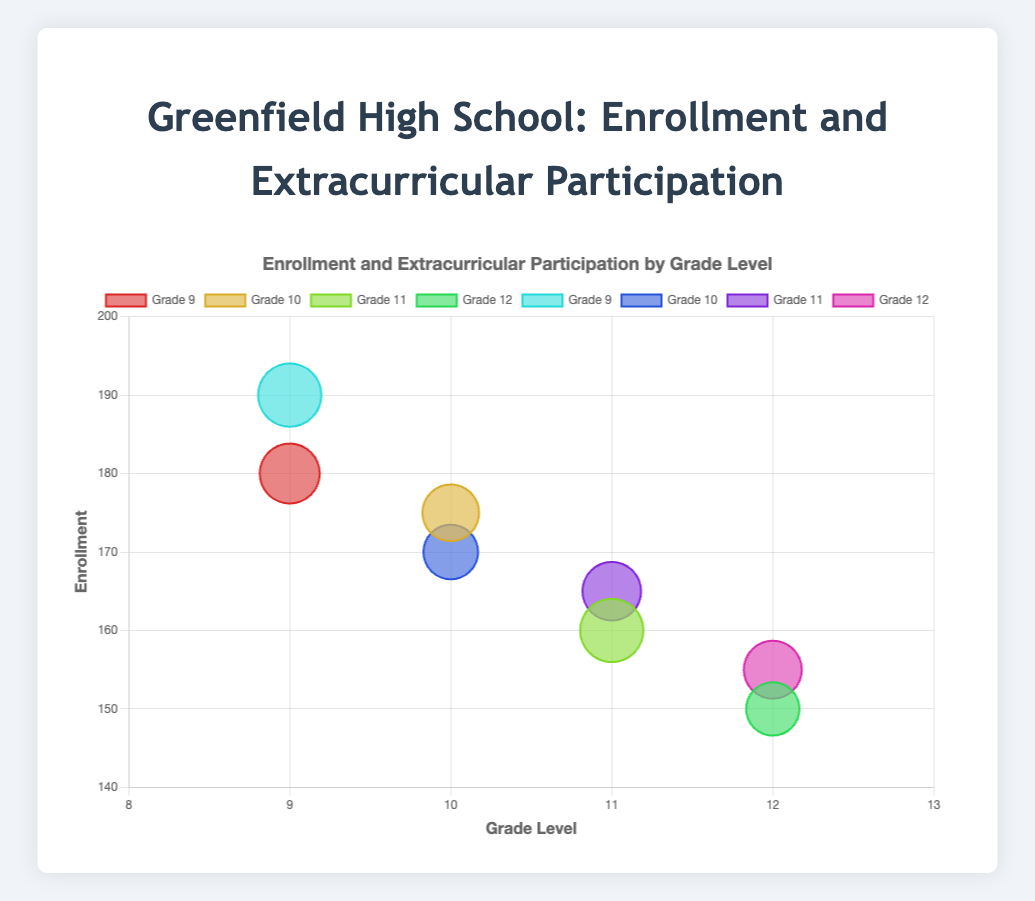What is the title of the chart? The title of the chart is located at the top and it reads "Enrollment and Extracurricular Participation by Grade Level."
Answer: Enrollment and Extracurricular Participation by Grade Level How many grade levels are displayed on the x-axis? The x-axis represents grade levels and ranges from Grade 9 to Grade 12.
Answer: Four (Grades 9, 10, 11, and 12) Which grade level has the bubble with the highest enrollment? By examining the y-axis (enrollment) and the bubble positions, we see that the highest enrollment is associated with Grade 9, which reaches 190.
Answer: Grade 9 What is the extracurricular participation percentage for the Grade 11 bubble with an enrollment of 160? The radius (r) of the bubble is proportional to extracurricular participation. By tooltip or data label, the Grade 11 bubble with an enrollment of 160 has a participation of 95%.
Answer: 95% What are the minimum and maximum enrollment values shown in the chart? The chart shows enrollment minima and maxima from the bubbles: The minimum enrollment is for Grade 12 at 150, and the maximum is for Grade 9 at 190.
Answer: Minimum: 150, Maximum: 190 Compare the extracurricular participation of the two Grade 12 data points. The two Grade 12 data points have extracurricular participation rates of 80% and 87% as shown by their bubble sizes and tooltips.
Answer: 80% and 87% Which grade level has the least variation in extracurricular participation? By comparing the bubbles for each grade level, Grade 10 has the least variation with participation rates of 85% and 82% (a difference of 3%).
Answer: Grade 10 If you average the enrollments for Grade 11, what value do you get? The enrollments for Grade 11 are 160 and 165. The average is (160 + 165) / 2 = 162.5.
Answer: 162.5 How does the enrollment trend from Grade 9 to Grade 12? Observing the bubbles from Grade 9 to Grade 12 on the y-axis shows a general decrease: 180, 190, 175, 170, 160, 165, 150, and 155.
Answer: It decreases Which grade level has the highest extracurricular participation, considering all data points? The maximum participation percentage is 95%, which is found in both Grade 11 and Grade 9.
Answer: Grades 9 and 11 